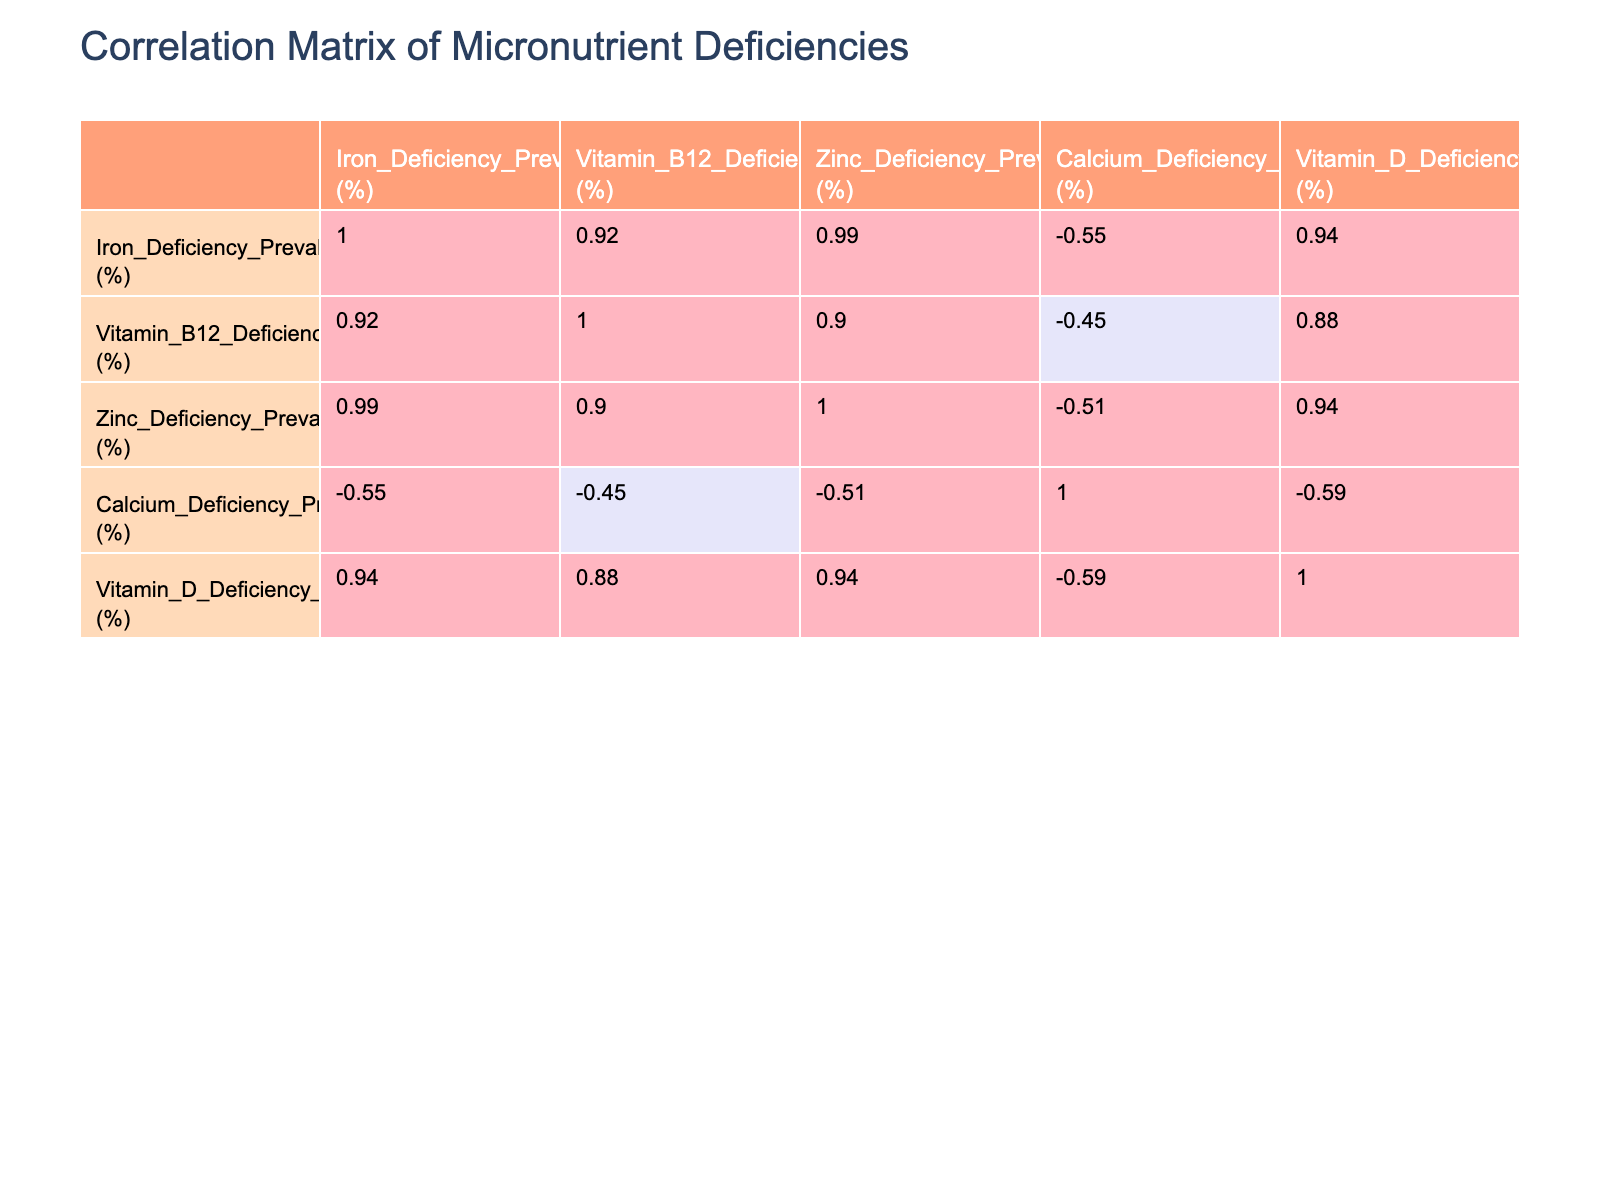What is the Iron Deficiency Prevalence for Vegans? According to the table, the Iron Deficiency Prevalence for Vegans is listed as 25%.
Answer: 25% Which dietary protein source has the highest prevalence of Vitamin B12 deficiency? Looking at the table, the Vegan group has the highest prevalence of Vitamin B12 deficiency at 40%.
Answer: 40% What is the average Zinc Deficiency Prevalence for Vegetarian and Vegan sources? The Zinc Deficiency Prevalence for Vegetarians is 20% and for Vegans is 30%, so the average is (20 + 30)/2 = 25%.
Answer: 25% Is it true that Mixed dietary protein sources have lower Calcium Deficiency Prevalence than Plant sources? Yes, the Calcium Deficiency Prevalence for Mixed sources is 14%, while for Plant sources it is 10%. Thus, Mixed has a higher prevalence.
Answer: Yes What is the difference in Iron Deficiency Prevalence between Plant and Animal sources? The Iron Deficiency Prevalence for Plant sources is 20% and for Animal sources is 5%, thus the difference is 20 - 5 = 15%.
Answer: 15% Which dietary source has the lowest prevalence of Calcium Deficiency? Referring to the table, the Plant source has the lowest prevalence of Calcium Deficiency at 10%.
Answer: 10% How do the Vitamin D deficiency rates compare between Omnivores and Flexitarians? The Vitamin D Deficiency Prevalence for Omnivores is 18% and for Flexitarians is 15%. Omnivores have a higher prevalence by a margin of 3%.
Answer: 3% Is it correct that all protein sources with plant-based origins have a Vitamin D Deficiency Prevalence above 20%? No, the Vegetarian group has a Vitamin D Deficiency Prevalence of 28%, which is above 20%, but the Plant source has 30%, making the assertion incorrect.
Answer: No What is the rank order of dietary protein sources from highest to lowest for Calcium Deficiency Prevalence? The Calcium Deficiency Prevalence rank is Animal (15%), Mixed (14%), Omnivore (12%), Vegan (12%), Flexitarian (10%), Plant (10%), and Vegetarian (8%). Thus, the order from highest to lowest is: Animal, Mixed, Omnivore, Vegan, Flexitarian, Plant, Vegetarian.
Answer: Animal, Mixed, Omnivore, Vegan, Flexitarian, Plant, Vegetarian 